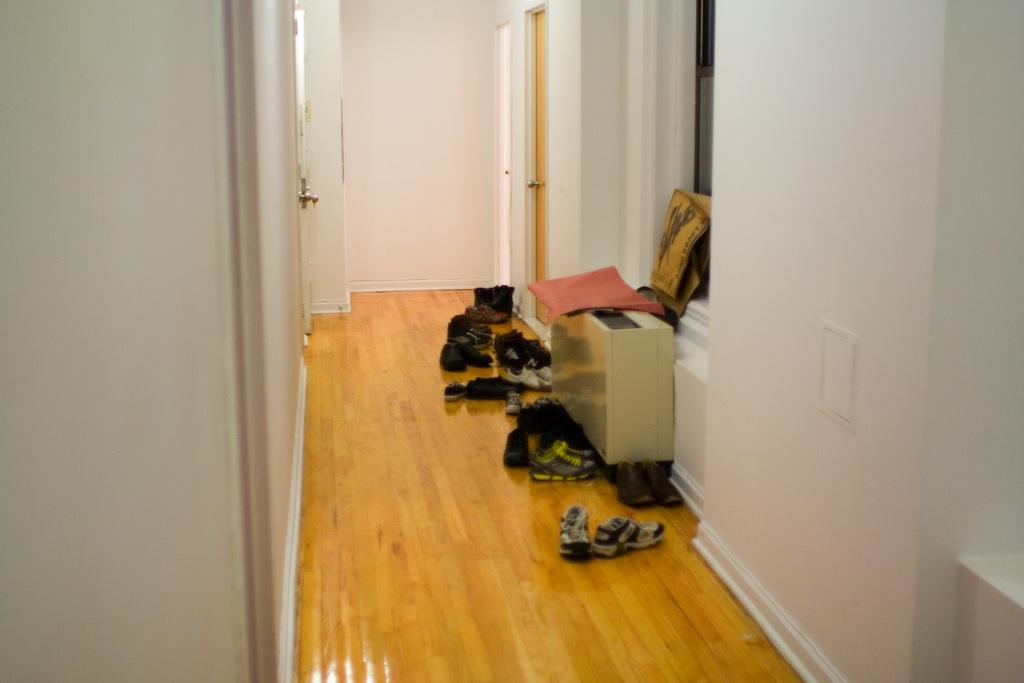What type of openings can be seen in the image? There are doors and a window in the image. What type of structure is visible in the image? There is a wall in the image. What type of footwear is present in the image? There are pairs of shoes in the image. Where might this image have been taken? The image may have been taken in a house, given the presence of doors, a window, and a wall. How much snow is visible on the ground in the image? There is no snow visible in the image; it does not mention any snow or outdoor setting. What type of season is depicted in the image? The image does not depict a specific season, as there are no seasonal cues present. 